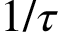<formula> <loc_0><loc_0><loc_500><loc_500>1 / \tau</formula> 